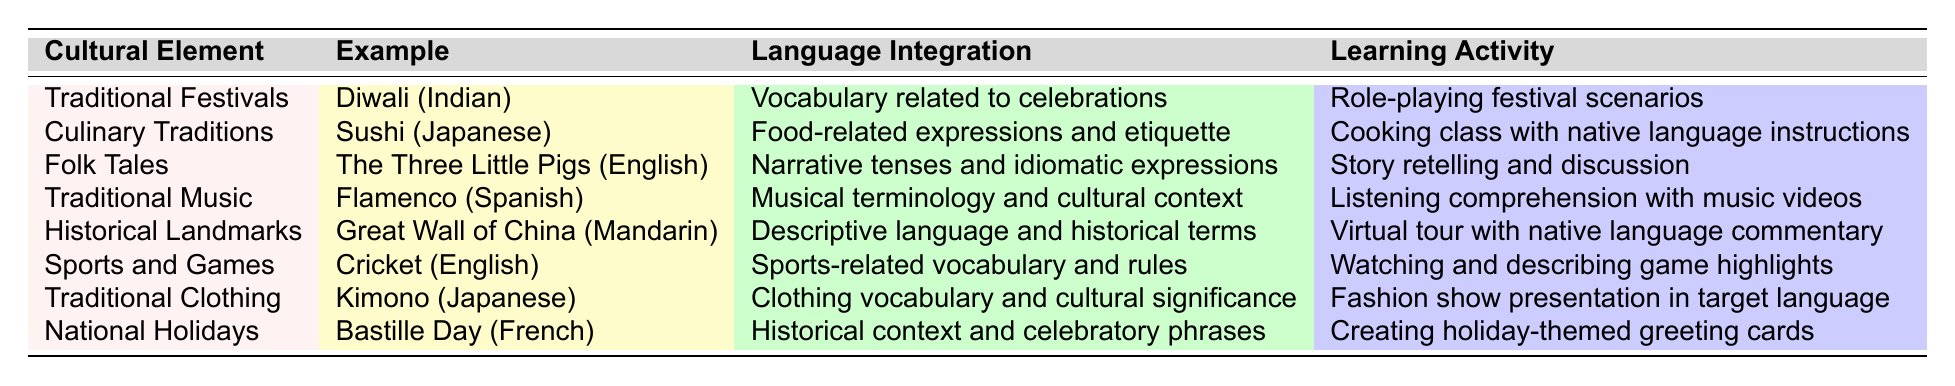What cultural element is associated with sushi? The table indicates that sushi is an example of Culinary Traditions.
Answer: Culinary Traditions Which learning activity is linked to traditional music? According to the table, the activity associated with traditional music (Flamenco) is listening comprehension with music videos.
Answer: Listening comprehension with music videos How many learning activities involve role-playing? The table shows one activity involving role-playing, which is for Traditional Festivals (Diwali).
Answer: One Is 'Bastille Day' related to any of the listed cultural elements? The table lists Bastille Day under National Holidays, confirming its relation to a cultural element.
Answer: Yes What is the language integration related to the Great Wall of China? The table states that the language integration related to the Great Wall of China is descriptive language and historical terms.
Answer: Descriptive language and historical terms Are there any learning activities that include food-related vocabulary and etiquette? The table specifies that Culinary Traditions (Sushi) include a cooking class with native language instructions, which relates to food-related vocabulary and etiquette.
Answer: Yes Which cultural element demonstrates the use of narrative tenses? The Folk Tales (The Three Little Pigs) include narrative tenses as part of the language integration.
Answer: Folk Tales What is the combined focus of the learning activities for Traditional Festivals and National Holidays? The focus for Traditional Festivals is role-playing festival scenarios, while for National Holidays it's creating holiday-themed greeting cards. Therefore, they emphasize practical engagement with cultural celebrations.
Answer: Practical engagement with cultural celebrations How do sports-related vocabulary and rules integrate into language learning? The table correlates the engagement with sports and games using language related to cricket, demonstrating the integration of vocabulary and rules into language learning activities.
Answer: Through sports and games using language related to cricket Which cultural element includes a cooking class as a learning activity? The table indicates that Culinary Traditions (Sushi) includes a cooking class with native language instructions.
Answer: Culinary Traditions 